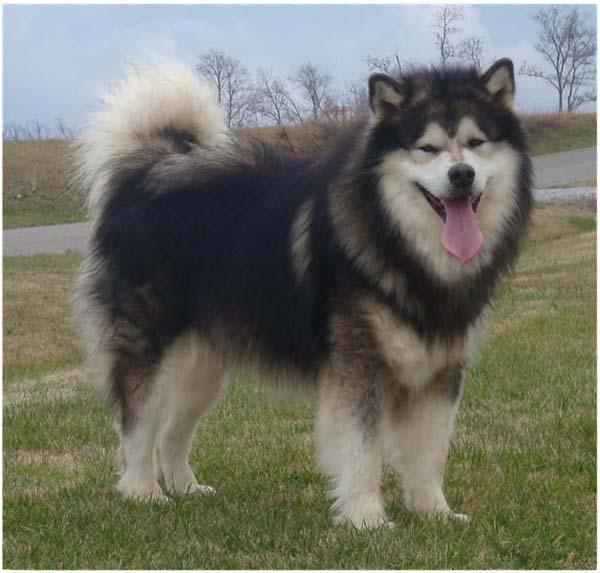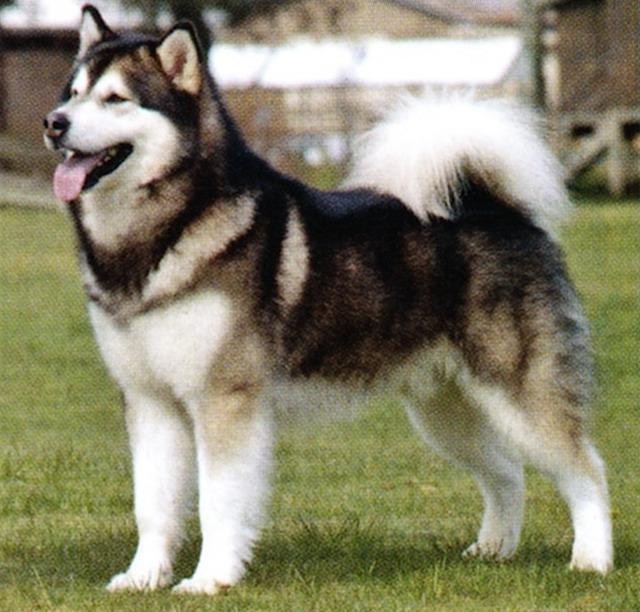The first image is the image on the left, the second image is the image on the right. Given the left and right images, does the statement "Both dogs have their mouths open." hold true? Answer yes or no. Yes. The first image is the image on the left, the second image is the image on the right. For the images shown, is this caption "There are two dogs with their mouths open." true? Answer yes or no. Yes. 